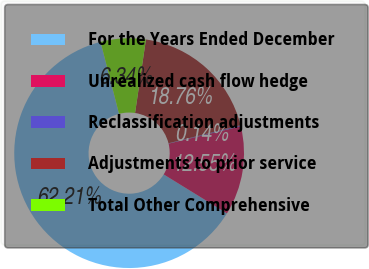Convert chart. <chart><loc_0><loc_0><loc_500><loc_500><pie_chart><fcel>For the Years Ended December<fcel>Unrealized cash flow hedge<fcel>Reclassification adjustments<fcel>Adjustments to prior service<fcel>Total Other Comprehensive<nl><fcel>62.21%<fcel>12.55%<fcel>0.14%<fcel>18.76%<fcel>6.34%<nl></chart> 